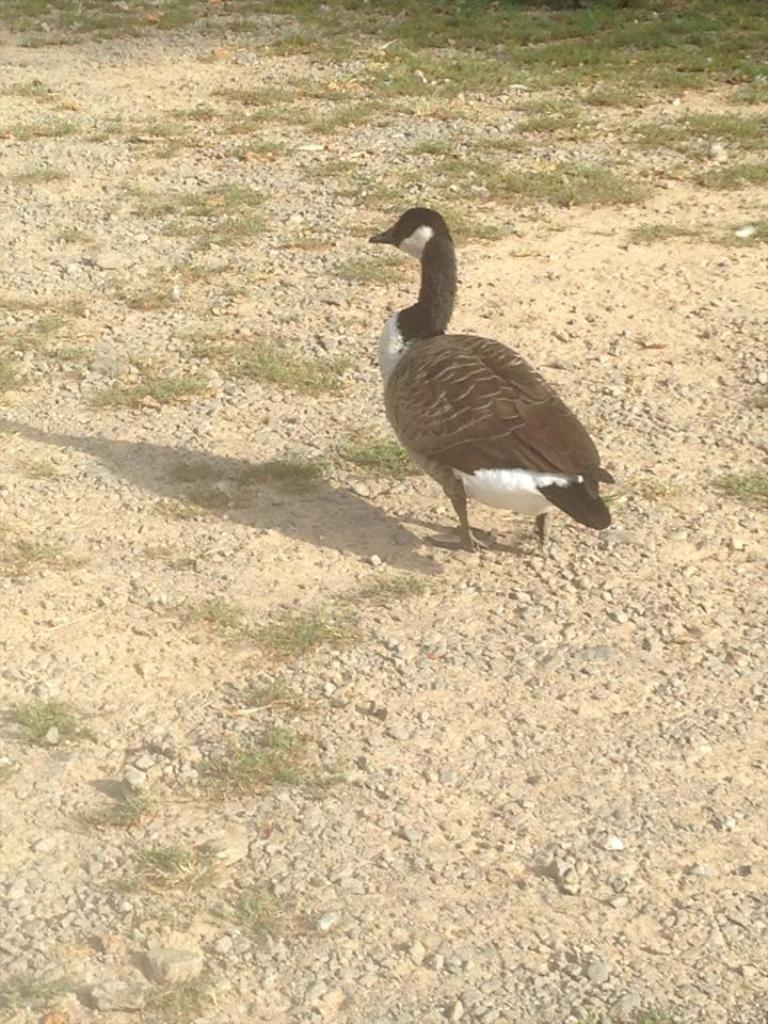What type of bird is in the image? There is a Canada goose bird in the image. What is the bird's position in the image? The bird is standing on the surface. What type of vegetation is visible in front of the bird? There is grass in front of the bird. How many chairs can be seen in the image? There are no chairs present in the image. What type of yak is visible in the image? There is no yak present in the image. 